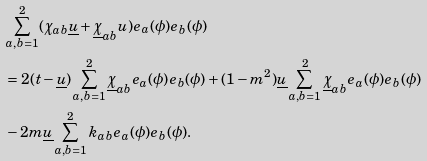<formula> <loc_0><loc_0><loc_500><loc_500>& \sum _ { a , b = 1 } ^ { 2 } ( \chi _ { a b } \underline { u } + \underline { \chi } _ { a b } u ) e _ { a } ( \phi ) e _ { b } ( \phi ) \\ & = 2 ( t - \underline { u } ) \sum _ { a , b = 1 } ^ { 2 } \underline { \chi } _ { a b } e _ { a } ( \phi ) e _ { b } ( \phi ) + ( 1 - m ^ { 2 } ) \underline { u } \sum _ { a , b = 1 } ^ { 2 } \underline { \chi } _ { a b } e _ { a } ( \phi ) e _ { b } ( \phi ) \\ & - 2 m \underline { u } \sum _ { a , b = 1 } ^ { 2 } k _ { a b } e _ { a } ( \phi ) e _ { b } ( \phi ) . \\</formula> 